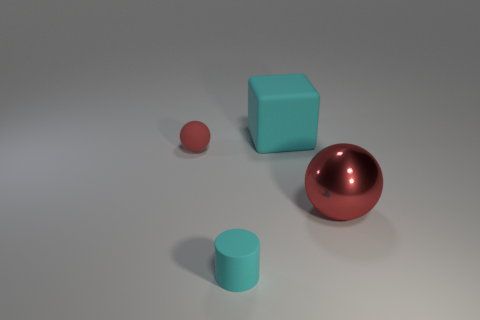Add 4 small purple metal balls. How many objects exist? 8 Add 2 yellow metallic spheres. How many yellow metallic spheres exist? 2 Subtract 0 gray cylinders. How many objects are left? 4 Subtract all cylinders. How many objects are left? 3 Subtract 1 blocks. How many blocks are left? 0 Subtract all brown spheres. Subtract all cyan cylinders. How many spheres are left? 2 Subtract all green cylinders. How many yellow spheres are left? 0 Subtract all large objects. Subtract all tiny blue cylinders. How many objects are left? 2 Add 1 small cyan things. How many small cyan things are left? 2 